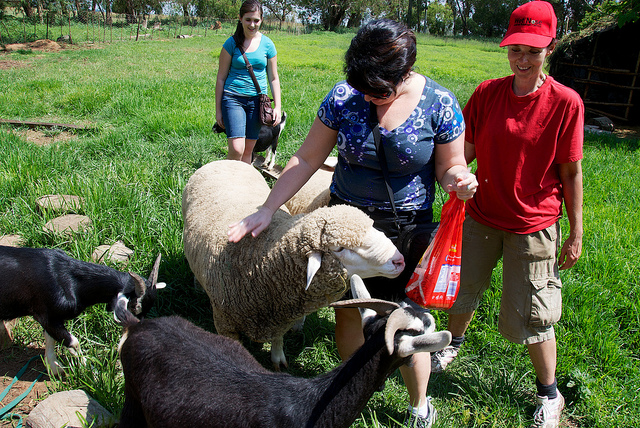What animals can be seen in this image? In the image, there are sheep and goats visible. The sheep stands out because of its thick wool, while the goats have slimmer bodies and distinct horns. Both types of animals appear to be comfortably interacting with the people in the image. 